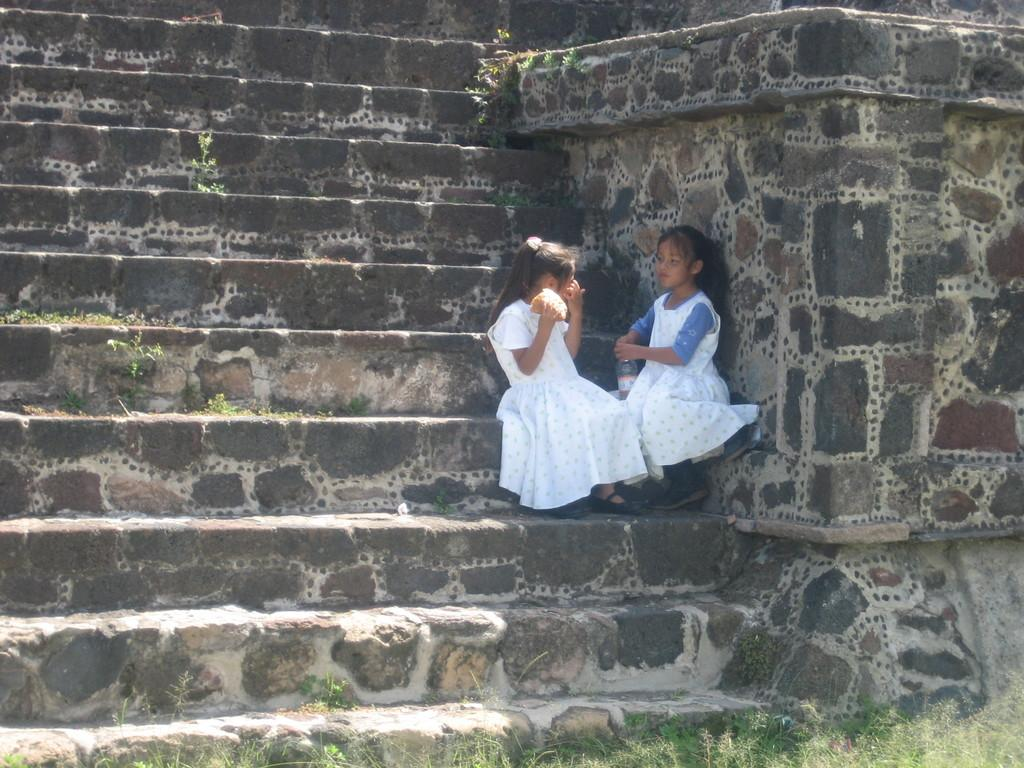How many girls are present in the image? There are 2 girls in the image. What are the girls doing in the image? The girls are sitting. What object can be seen in the image besides the girls? There is a bottle in the image. What architectural feature is visible in the image? There are steps in the image. What can be seen in the background of the image? There is a wall in the image. What type of vegetation is present in the image? There are plants in the image. What type of bedroom can be seen in the image? There is no bedroom present in the image. What is the girls' relation to each other in the image? The provided facts do not give any information about the girls' relation to each other. 